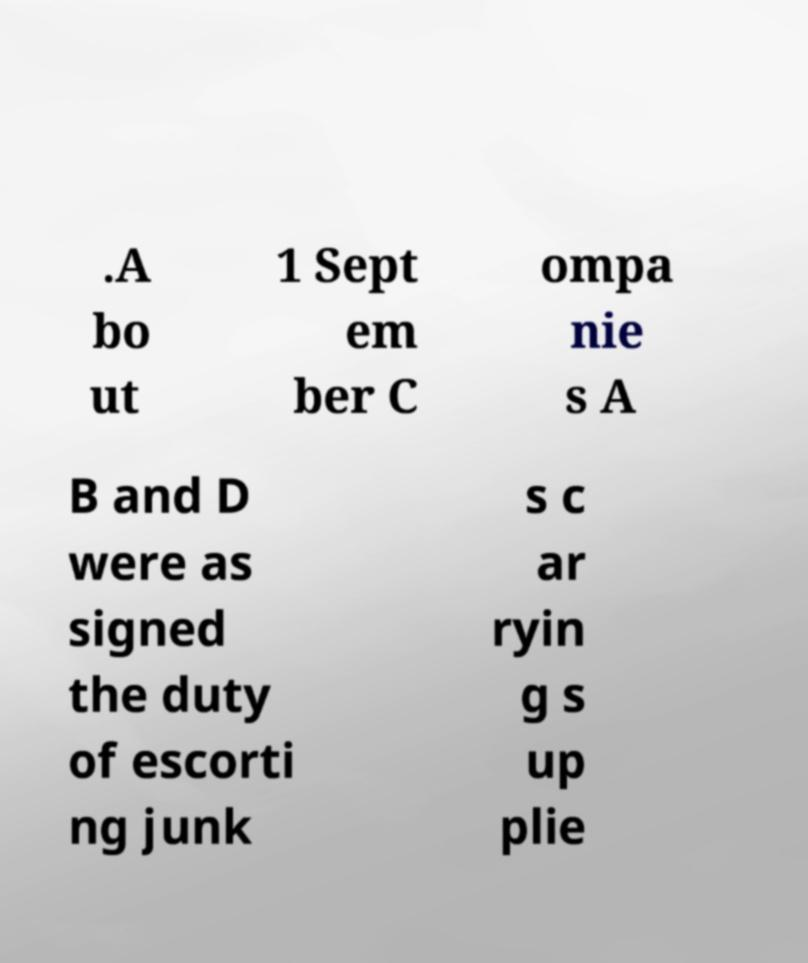There's text embedded in this image that I need extracted. Can you transcribe it verbatim? .A bo ut 1 Sept em ber C ompa nie s A B and D were as signed the duty of escorti ng junk s c ar ryin g s up plie 